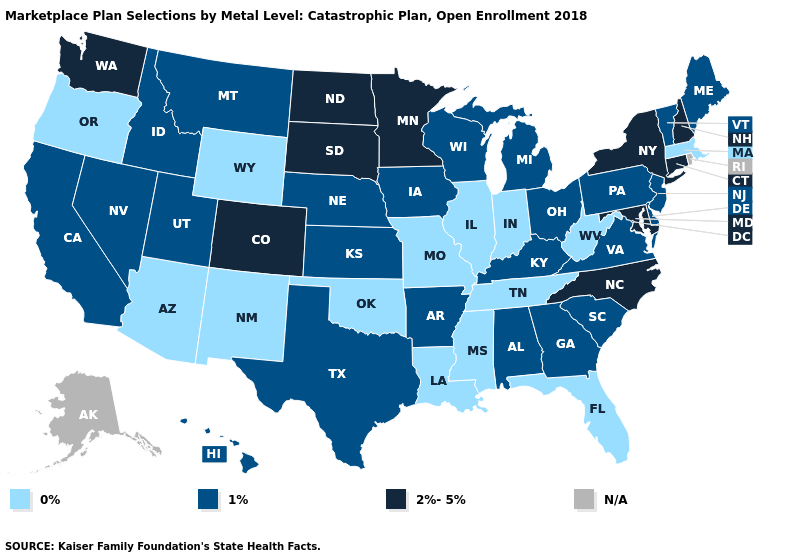What is the lowest value in the Northeast?
Answer briefly. 0%. Name the states that have a value in the range N/A?
Be succinct. Alaska, Rhode Island. What is the lowest value in states that border Idaho?
Quick response, please. 0%. Name the states that have a value in the range 1%?
Concise answer only. Alabama, Arkansas, California, Delaware, Georgia, Hawaii, Idaho, Iowa, Kansas, Kentucky, Maine, Michigan, Montana, Nebraska, Nevada, New Jersey, Ohio, Pennsylvania, South Carolina, Texas, Utah, Vermont, Virginia, Wisconsin. Name the states that have a value in the range N/A?
Answer briefly. Alaska, Rhode Island. Does Hawaii have the lowest value in the West?
Be succinct. No. Name the states that have a value in the range 1%?
Write a very short answer. Alabama, Arkansas, California, Delaware, Georgia, Hawaii, Idaho, Iowa, Kansas, Kentucky, Maine, Michigan, Montana, Nebraska, Nevada, New Jersey, Ohio, Pennsylvania, South Carolina, Texas, Utah, Vermont, Virginia, Wisconsin. Among the states that border New Jersey , which have the lowest value?
Short answer required. Delaware, Pennsylvania. What is the lowest value in the South?
Be succinct. 0%. What is the value of Hawaii?
Write a very short answer. 1%. What is the lowest value in the USA?
Be succinct. 0%. Name the states that have a value in the range N/A?
Concise answer only. Alaska, Rhode Island. Name the states that have a value in the range N/A?
Concise answer only. Alaska, Rhode Island. What is the value of California?
Write a very short answer. 1%. 